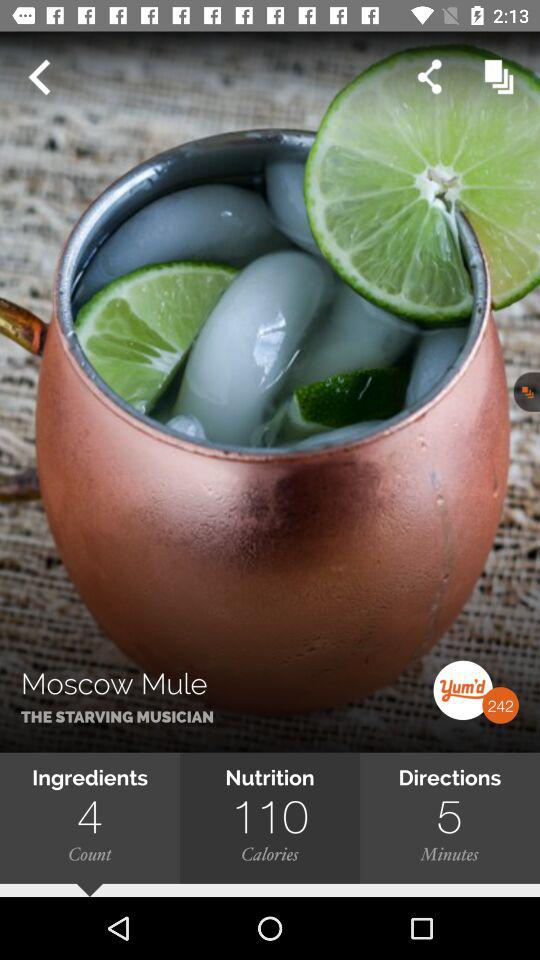What's the total number of ingredients? The total number of ingredients is 4. 